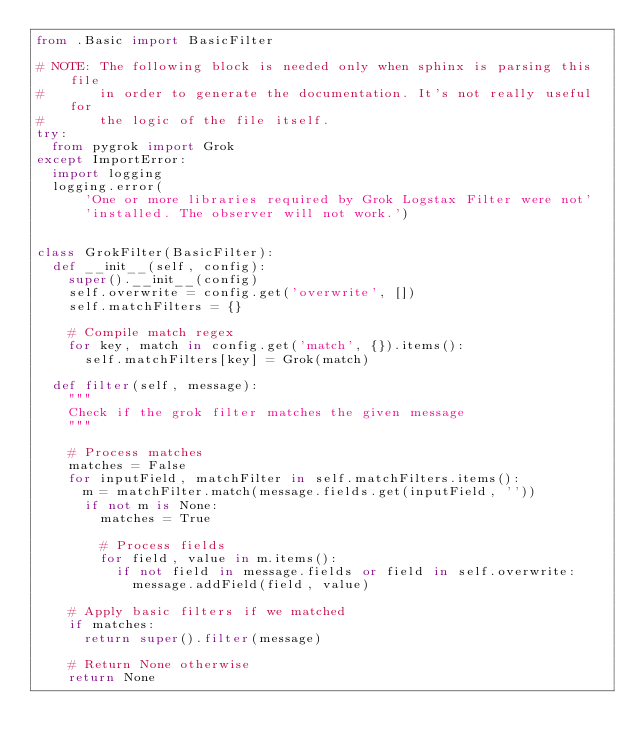<code> <loc_0><loc_0><loc_500><loc_500><_Python_>from .Basic import BasicFilter

# NOTE: The following block is needed only when sphinx is parsing this file
#       in order to generate the documentation. It's not really useful for
#       the logic of the file itself.
try:
  from pygrok import Grok
except ImportError:
  import logging
  logging.error(
      'One or more libraries required by Grok Logstax Filter were not'
      'installed. The observer will not work.')


class GrokFilter(BasicFilter):
  def __init__(self, config):
    super().__init__(config)
    self.overwrite = config.get('overwrite', [])
    self.matchFilters = {}

    # Compile match regex
    for key, match in config.get('match', {}).items():
      self.matchFilters[key] = Grok(match)

  def filter(self, message):
    """
    Check if the grok filter matches the given message
    """

    # Process matches
    matches = False
    for inputField, matchFilter in self.matchFilters.items():
      m = matchFilter.match(message.fields.get(inputField, ''))
      if not m is None:
        matches = True

        # Process fields
        for field, value in m.items():
          if not field in message.fields or field in self.overwrite:
            message.addField(field, value)

    # Apply basic filters if we matched
    if matches:
      return super().filter(message)

    # Return None otherwise
    return None
</code> 